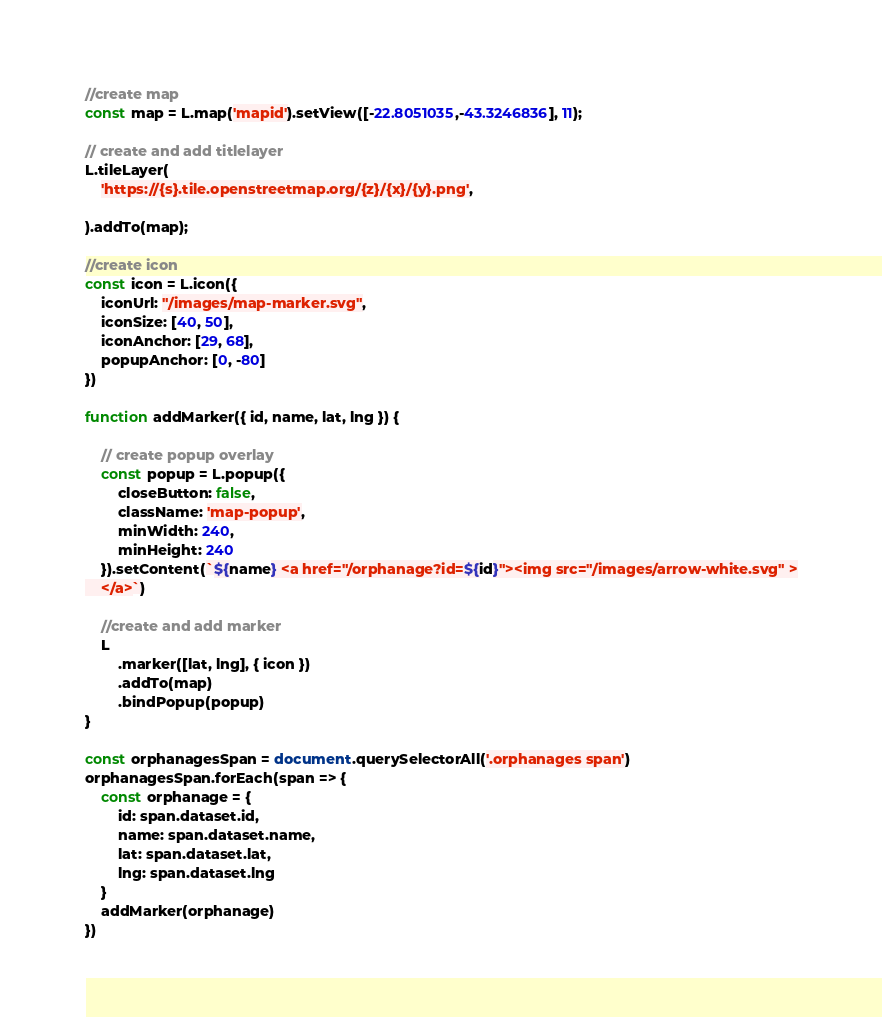<code> <loc_0><loc_0><loc_500><loc_500><_JavaScript_>//create map
const map = L.map('mapid').setView([-22.8051035,-43.3246836], 11);

// create and add titlelayer
L.tileLayer(    
    'https://{s}.tile.openstreetmap.org/{z}/{x}/{y}.png',

).addTo(map);

//create icon
const icon = L.icon({
    iconUrl: "/images/map-marker.svg",
    iconSize: [40, 50],
    iconAnchor: [29, 68],
    popupAnchor: [0, -80]
})

function addMarker({ id, name, lat, lng }) {

    // create popup overlay
    const popup = L.popup({
        closeButton: false,
        className: 'map-popup',
        minWidth: 240,
        minHeight: 240
    }).setContent(`${name} <a href="/orphanage?id=${id}"><img src="/images/arrow-white.svg" >
    </a>`)

    //create and add marker
    L
        .marker([lat, lng], { icon })
        .addTo(map)
        .bindPopup(popup)
}

const orphanagesSpan = document.querySelectorAll('.orphanages span')
orphanagesSpan.forEach(span => {
    const orphanage = {
        id: span.dataset.id,
        name: span.dataset.name,
        lat: span.dataset.lat,
        lng: span.dataset.lng
    }
    addMarker(orphanage)
})</code> 